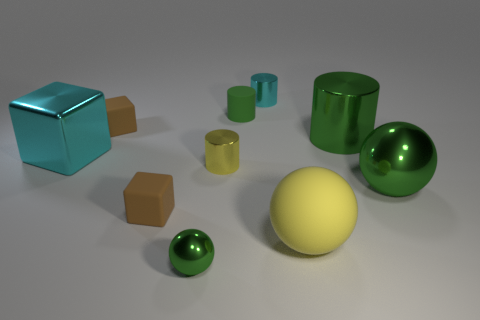Subtract 1 cylinders. How many cylinders are left? 3 Subtract all cyan cylinders. How many cylinders are left? 3 Subtract all blocks. How many objects are left? 7 Subtract all tiny cyan cubes. Subtract all tiny cyan metallic cylinders. How many objects are left? 9 Add 1 large cyan shiny things. How many large cyan shiny things are left? 2 Add 5 large yellow things. How many large yellow things exist? 6 Subtract 0 brown cylinders. How many objects are left? 10 